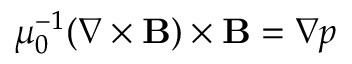Convert formula to latex. <formula><loc_0><loc_0><loc_500><loc_500>\mu _ { 0 } ^ { - 1 } ( \nabla \times B ) \times B = \nabla p</formula> 